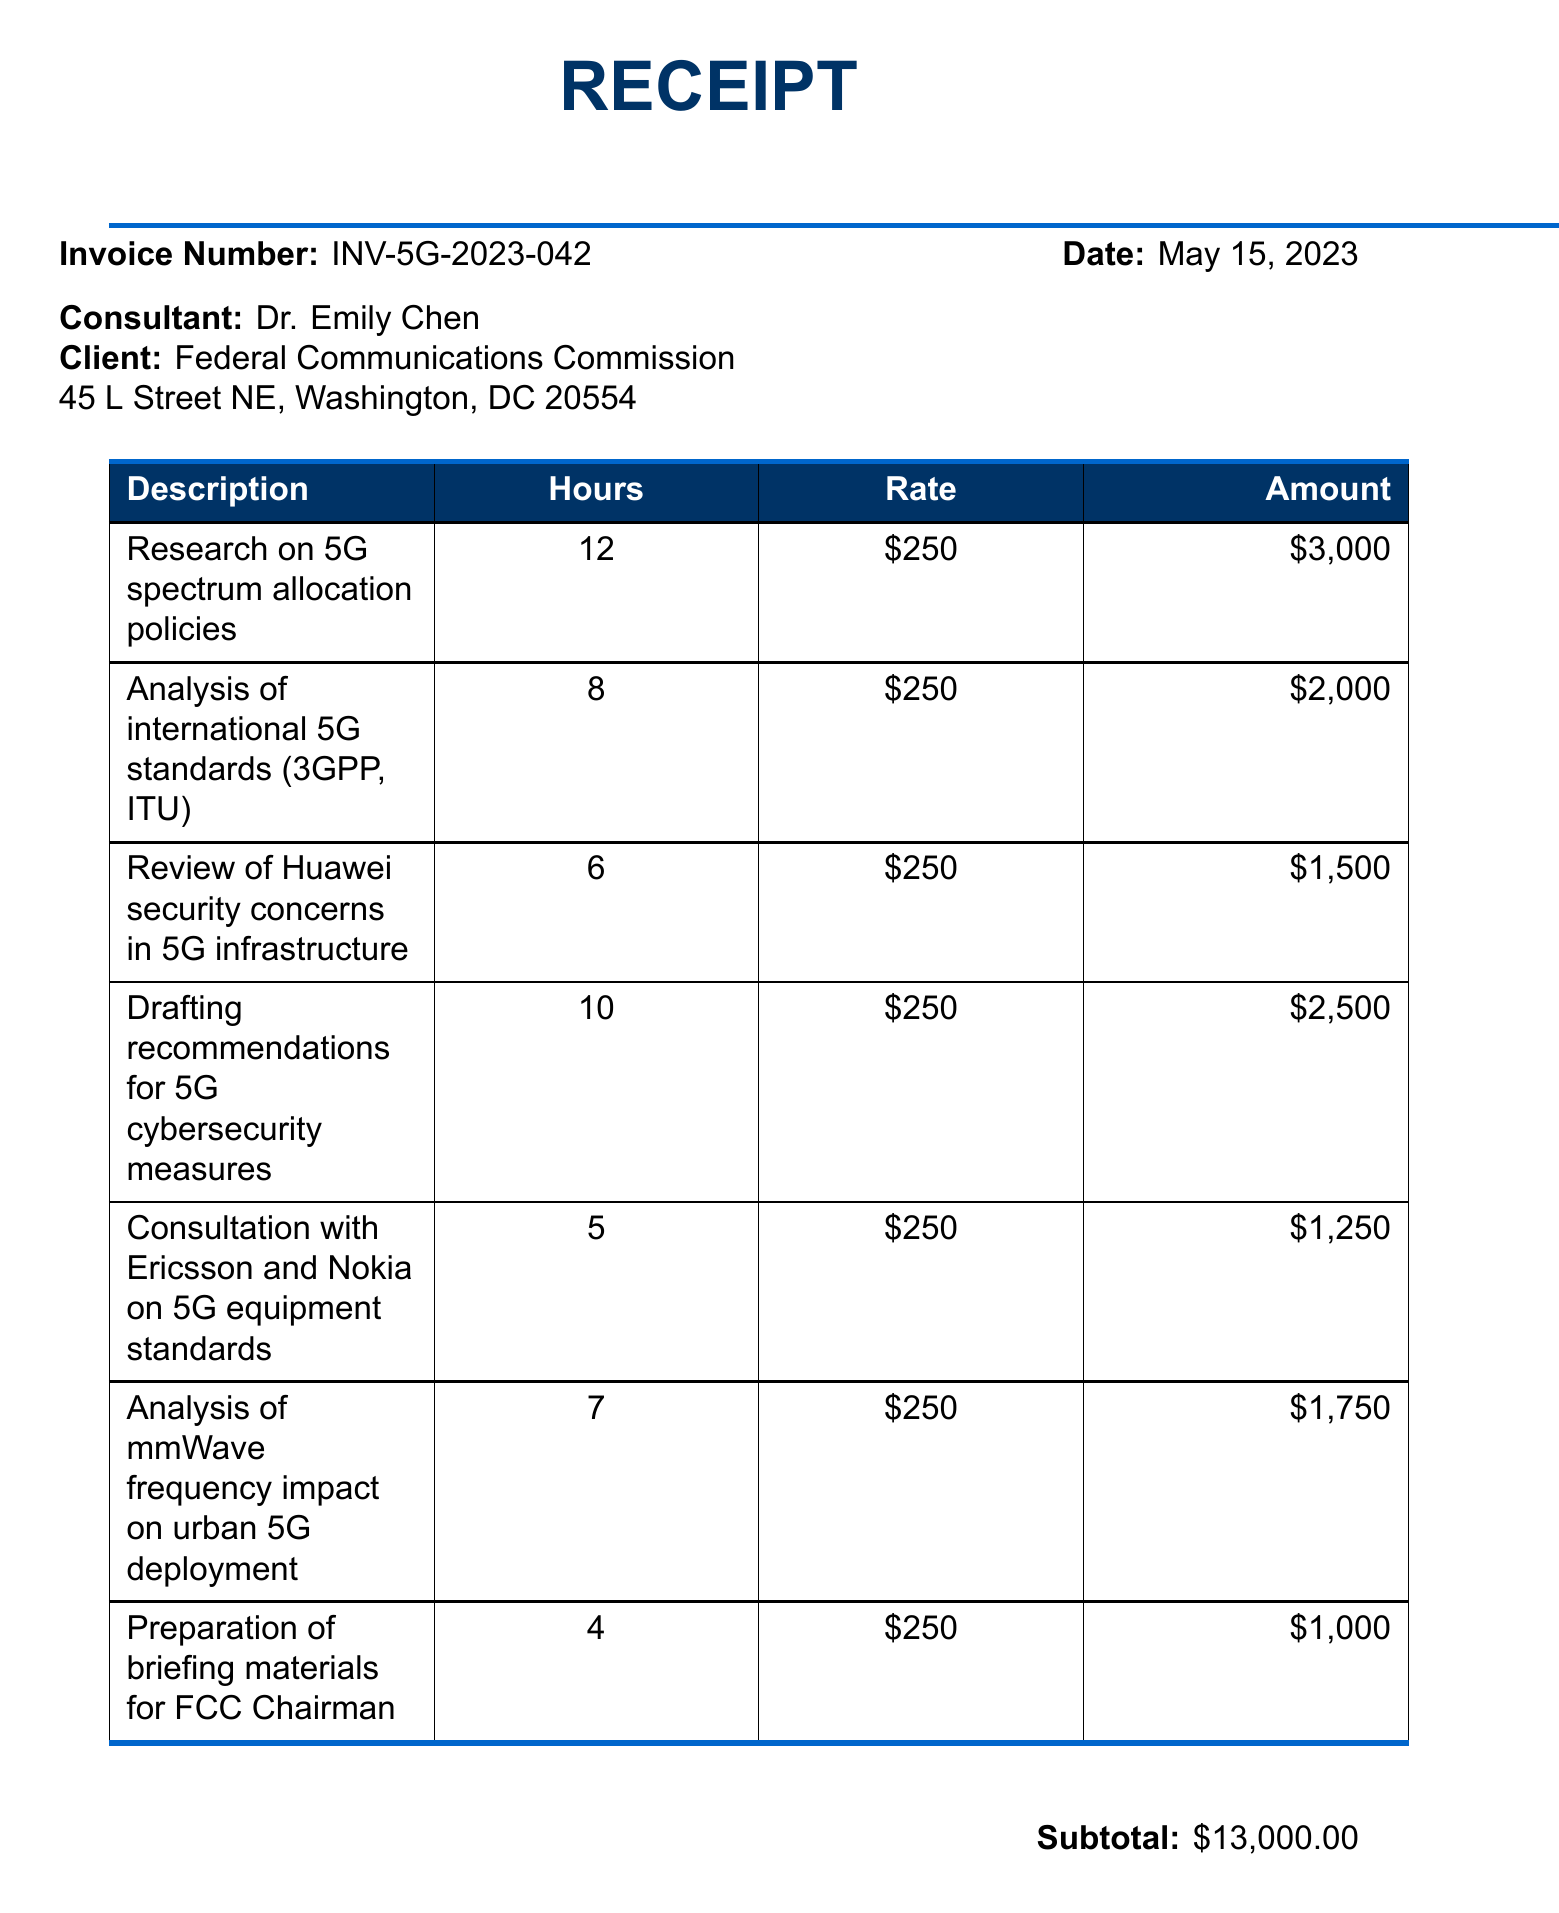What is the invoice number? The invoice number is explicitly listed in the document.
Answer: INV-5G-2023-042 Who is the consultant? The consultant's name appears prominently in the document.
Answer: Dr. Emily Chen How many hours were spent on drafting recommendations for cybersecurity measures? The number of hours for each line item is detailed in the document.
Answer: 10 What is the total amount due? The total amount is calculated and shown in the summary section of the document.
Answer: $13,780.00 What was the hourly rate for the consulting services? The rate per item is uniform and specified in each line of the invoice.
Answer: $250 What is the tax rate applied? The tax rate is mentioned in the total calculation area of the document.
Answer: 6% How many hours were dedicated to reviewing Huawei security concerns? Specific hours are listed for each activity performed, including this one.
Answer: 6 What payment terms are set for this invoice? Payment terms are clearly stated at the end of the invoice.
Answer: Net 30 What type of concerns were analyzed related to 5G? The notes section explains the focus areas of the consultation.
Answer: Security concerns 